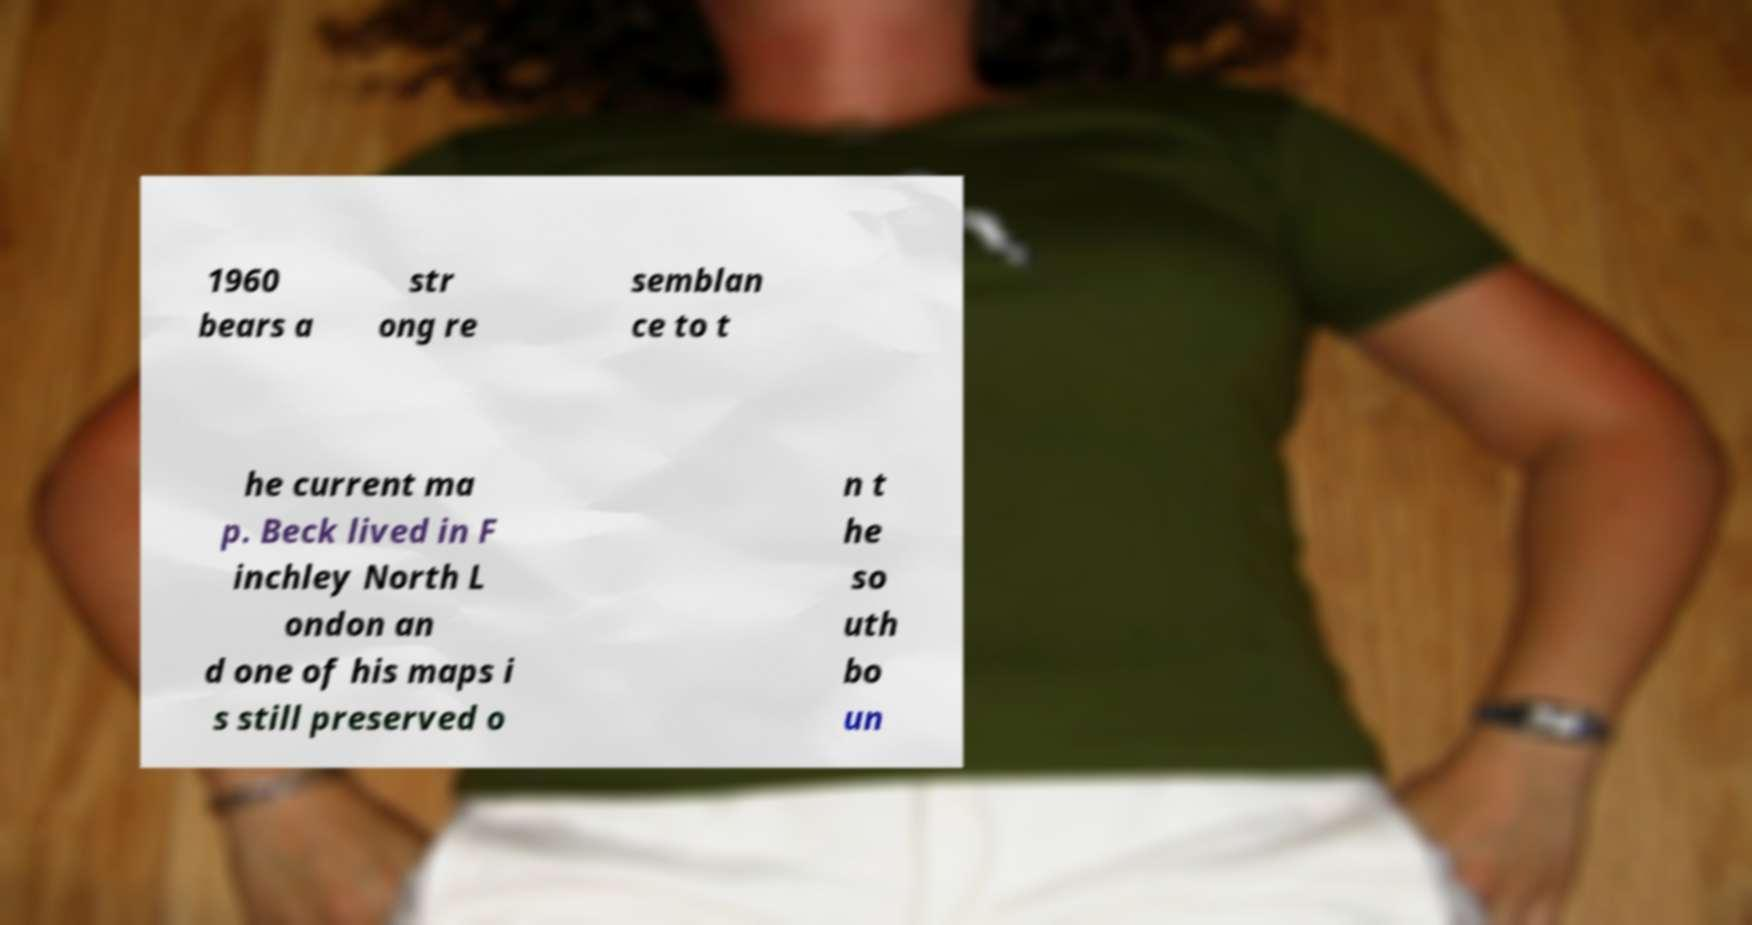What messages or text are displayed in this image? I need them in a readable, typed format. 1960 bears a str ong re semblan ce to t he current ma p. Beck lived in F inchley North L ondon an d one of his maps i s still preserved o n t he so uth bo un 